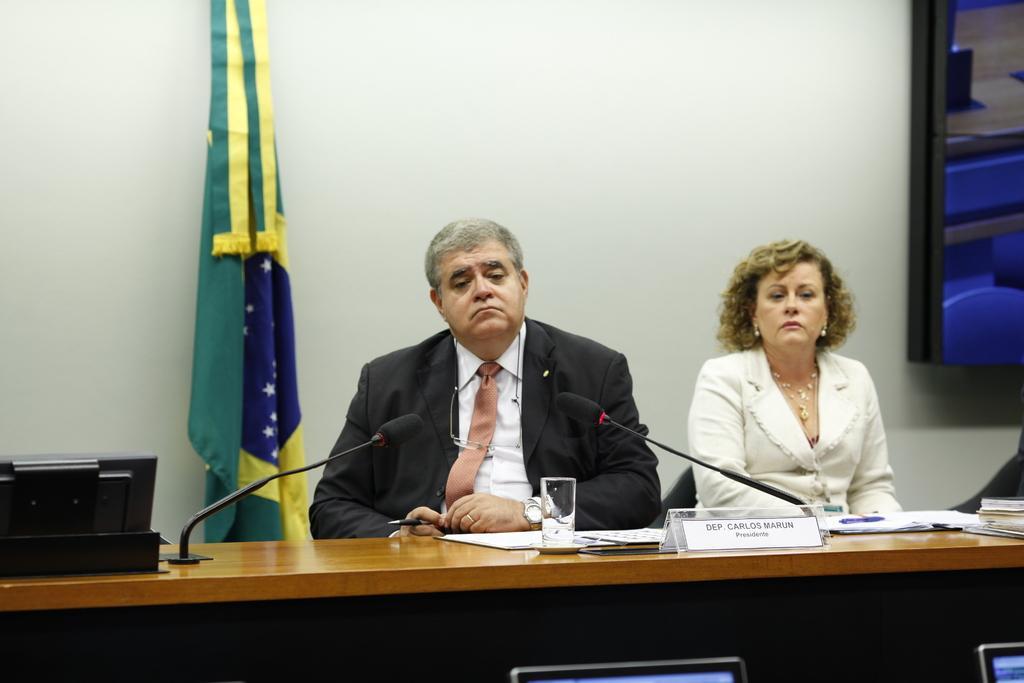In one or two sentences, can you explain what this image depicts? In this image in the front there are screens. In the center there is a table and on the table there are mice, there are papers and there are books and on the left side there is an object which is black in colour. In the background there are persons sitting, there is a flag and there is a wall. On the right side there is a frame on the wall. 